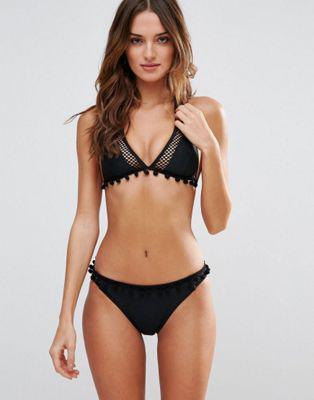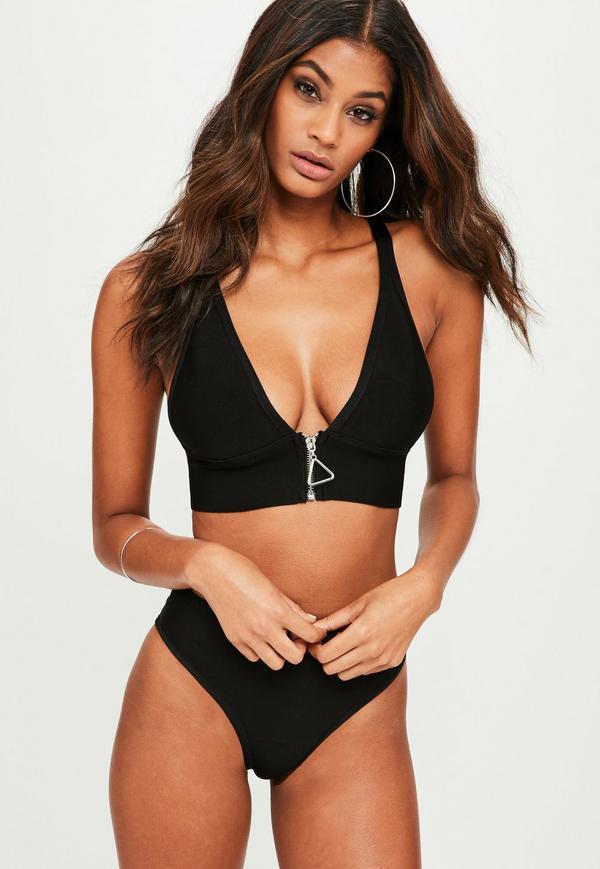The first image is the image on the left, the second image is the image on the right. Examine the images to the left and right. Is the description "Both bottoms are solid black." accurate? Answer yes or no. Yes. The first image is the image on the left, the second image is the image on the right. Given the left and right images, does the statement "Each model is wearing a black bikini top and bottom." hold true? Answer yes or no. Yes. 